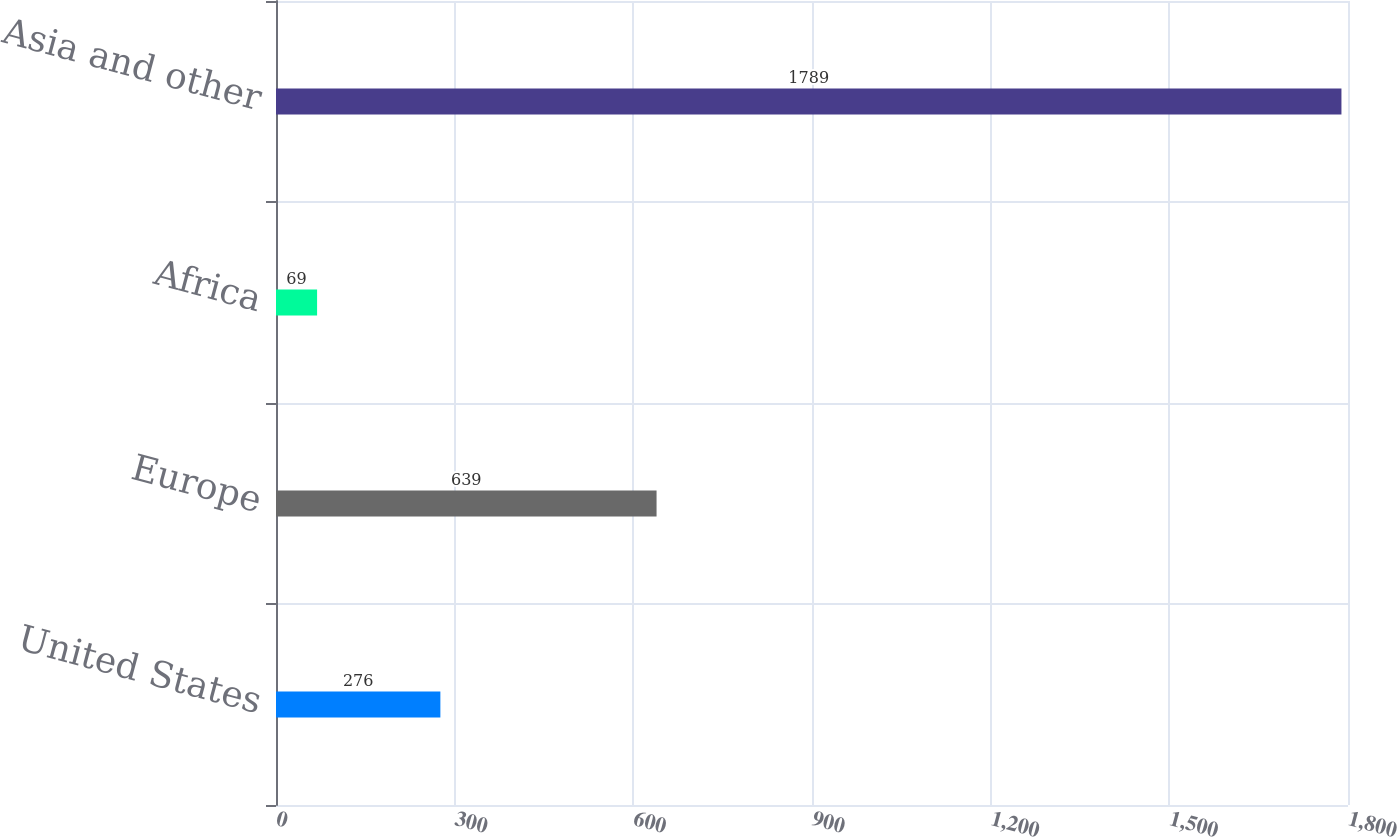Convert chart. <chart><loc_0><loc_0><loc_500><loc_500><bar_chart><fcel>United States<fcel>Europe<fcel>Africa<fcel>Asia and other<nl><fcel>276<fcel>639<fcel>69<fcel>1789<nl></chart> 